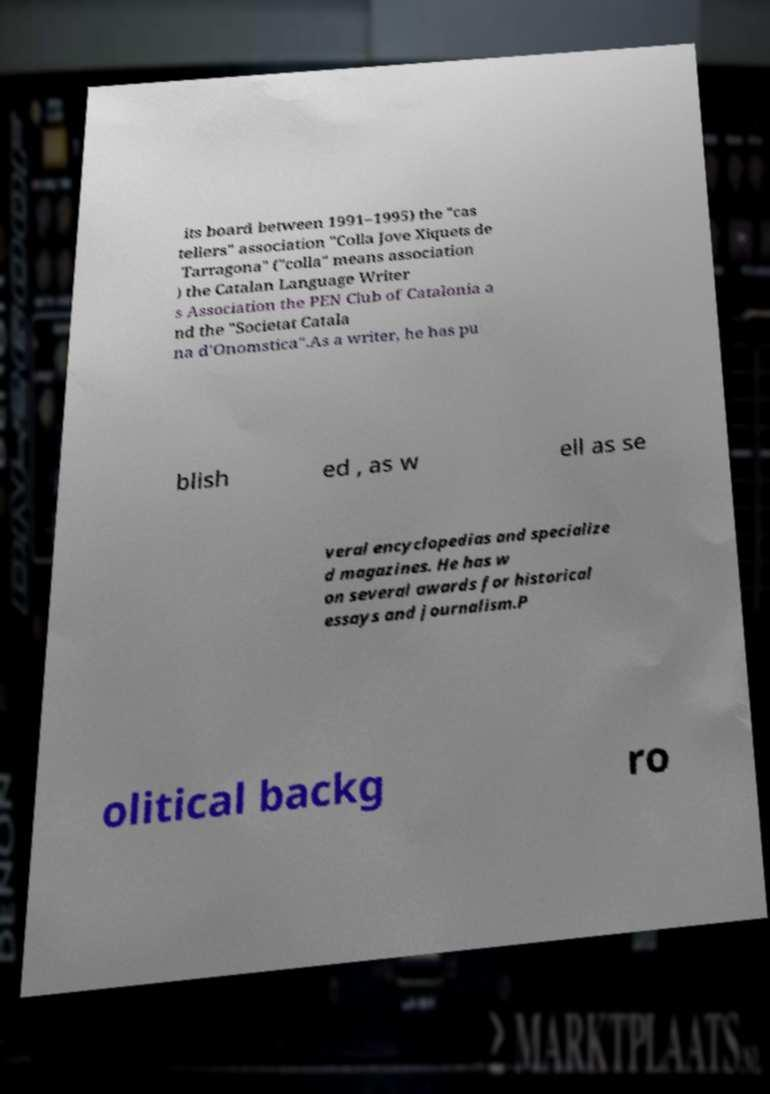Can you read and provide the text displayed in the image?This photo seems to have some interesting text. Can you extract and type it out for me? its board between 1991–1995) the "cas tellers" association "Colla Jove Xiquets de Tarragona" ("colla" means association ) the Catalan Language Writer s Association the PEN Club of Catalonia a nd the "Societat Catala na d'Onomstica".As a writer, he has pu blish ed , as w ell as se veral encyclopedias and specialize d magazines. He has w on several awards for historical essays and journalism.P olitical backg ro 